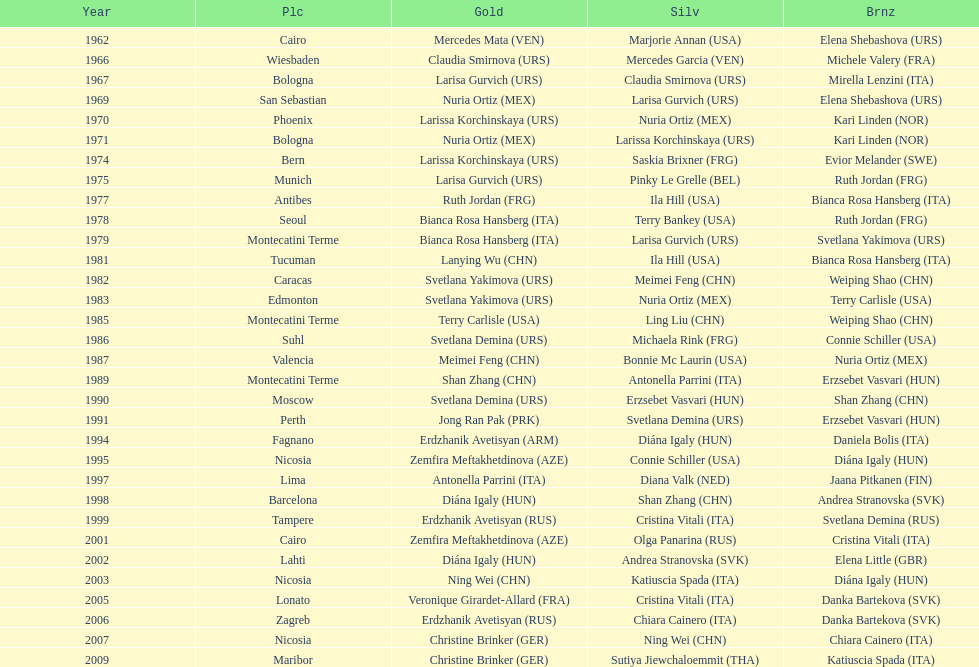How many gold did u.s.a win 1. 